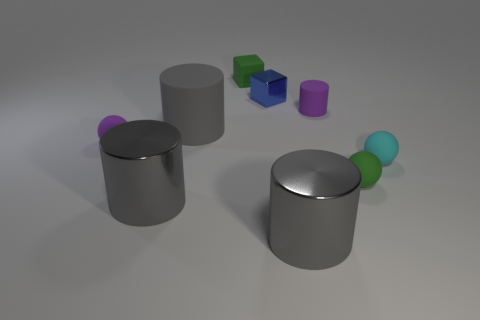What material is the tiny ball that is both to the right of the green matte cube and behind the green sphere?
Offer a very short reply. Rubber. Is the size of the green rubber object that is behind the cyan matte sphere the same as the small cyan object?
Provide a short and direct response. Yes. There is a tiny metallic thing; what shape is it?
Offer a terse response. Cube. What number of cyan matte objects are the same shape as the tiny blue thing?
Provide a succinct answer. 0. What number of objects are in front of the small metal cube and behind the small cylinder?
Offer a terse response. 0. What is the color of the small cylinder?
Make the answer very short. Purple. Is there a big object that has the same material as the small blue block?
Keep it short and to the point. Yes. Are there any purple things that are on the left side of the cylinder to the left of the big rubber object that is behind the cyan thing?
Offer a terse response. Yes. Are there any big matte objects left of the purple ball?
Ensure brevity in your answer.  No. Is there a shiny object that has the same color as the big matte object?
Offer a very short reply. Yes. 